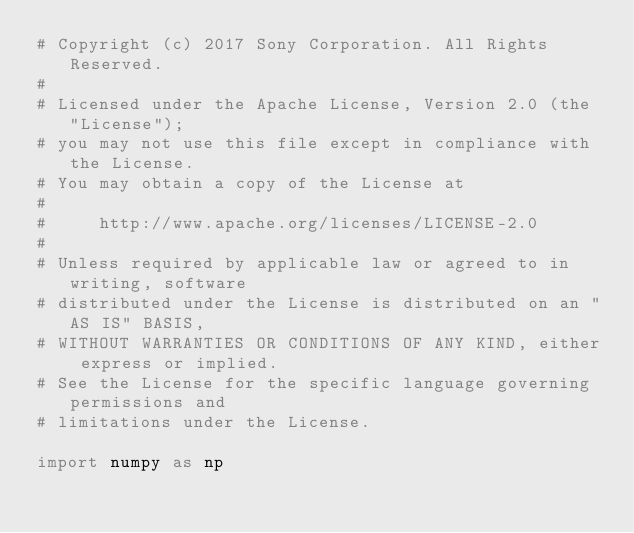Convert code to text. <code><loc_0><loc_0><loc_500><loc_500><_Python_># Copyright (c) 2017 Sony Corporation. All Rights Reserved.
#
# Licensed under the Apache License, Version 2.0 (the "License");
# you may not use this file except in compliance with the License.
# You may obtain a copy of the License at
#
#     http://www.apache.org/licenses/LICENSE-2.0
#
# Unless required by applicable law or agreed to in writing, software
# distributed under the License is distributed on an "AS IS" BASIS,
# WITHOUT WARRANTIES OR CONDITIONS OF ANY KIND, either express or implied.
# See the License for the specific language governing permissions and
# limitations under the License.

import numpy as np
</code> 